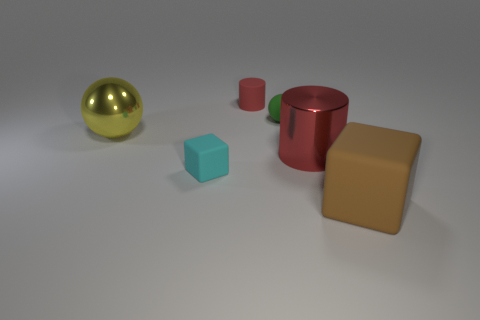How many big objects are both behind the small cyan thing and on the right side of the small green thing?
Offer a very short reply. 1. There is a red thing that is the same size as the brown rubber thing; what material is it?
Your response must be concise. Metal. Does the ball to the right of the large yellow metallic ball have the same size as the matte cube that is behind the brown block?
Your answer should be compact. Yes. There is a tiny cyan rubber block; are there any large cylinders right of it?
Your response must be concise. Yes. The small thing in front of the big shiny object that is behind the large red metallic cylinder is what color?
Offer a very short reply. Cyan. Is the number of large metal objects less than the number of small matte objects?
Offer a terse response. Yes. How many tiny red objects have the same shape as the yellow object?
Offer a terse response. 0. There is a rubber cube that is the same size as the red matte cylinder; what color is it?
Your answer should be compact. Cyan. Are there the same number of small matte objects behind the yellow ball and tiny matte spheres in front of the tiny cyan block?
Keep it short and to the point. No. Are there any brown rubber blocks that have the same size as the yellow metal object?
Make the answer very short. Yes. 